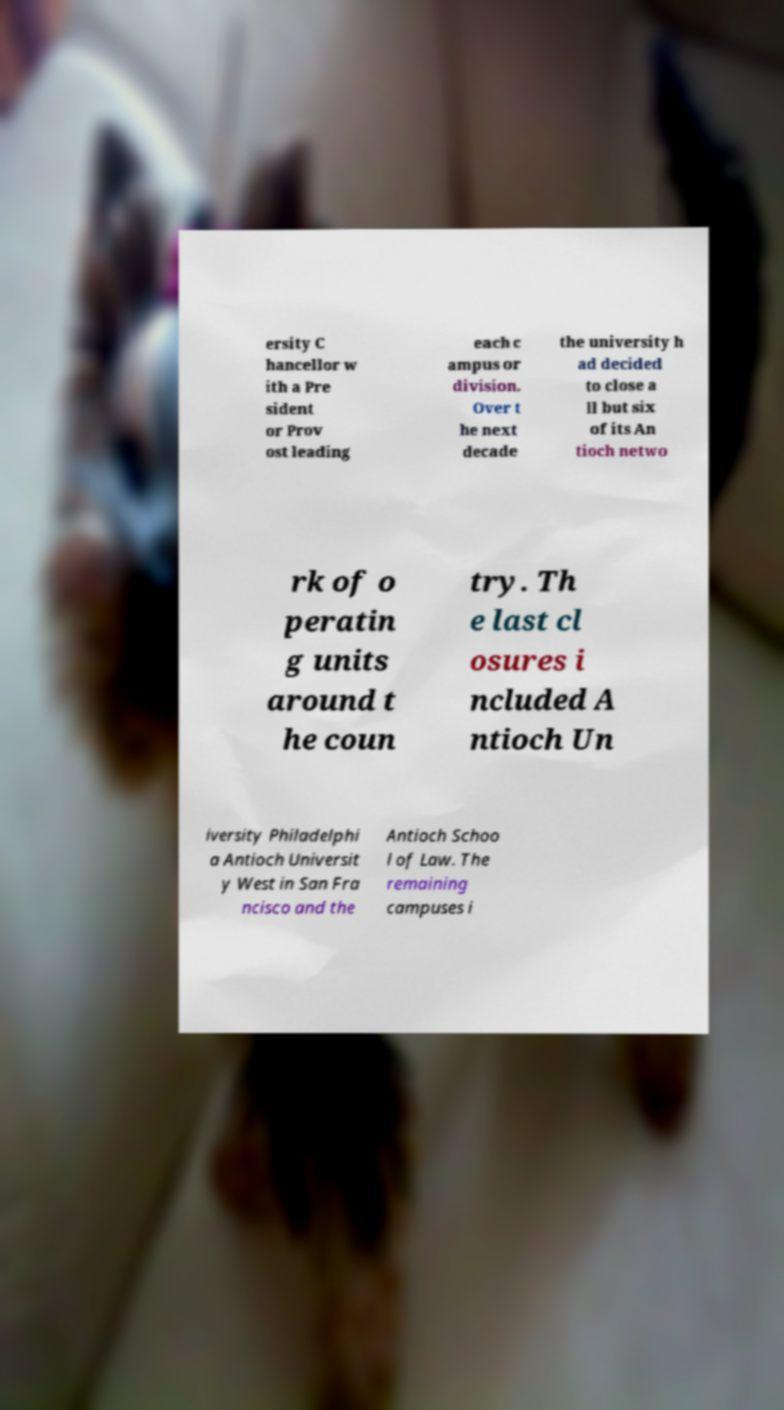There's text embedded in this image that I need extracted. Can you transcribe it verbatim? ersity C hancellor w ith a Pre sident or Prov ost leading each c ampus or division. Over t he next decade the university h ad decided to close a ll but six of its An tioch netwo rk of o peratin g units around t he coun try. Th e last cl osures i ncluded A ntioch Un iversity Philadelphi a Antioch Universit y West in San Fra ncisco and the Antioch Schoo l of Law. The remaining campuses i 